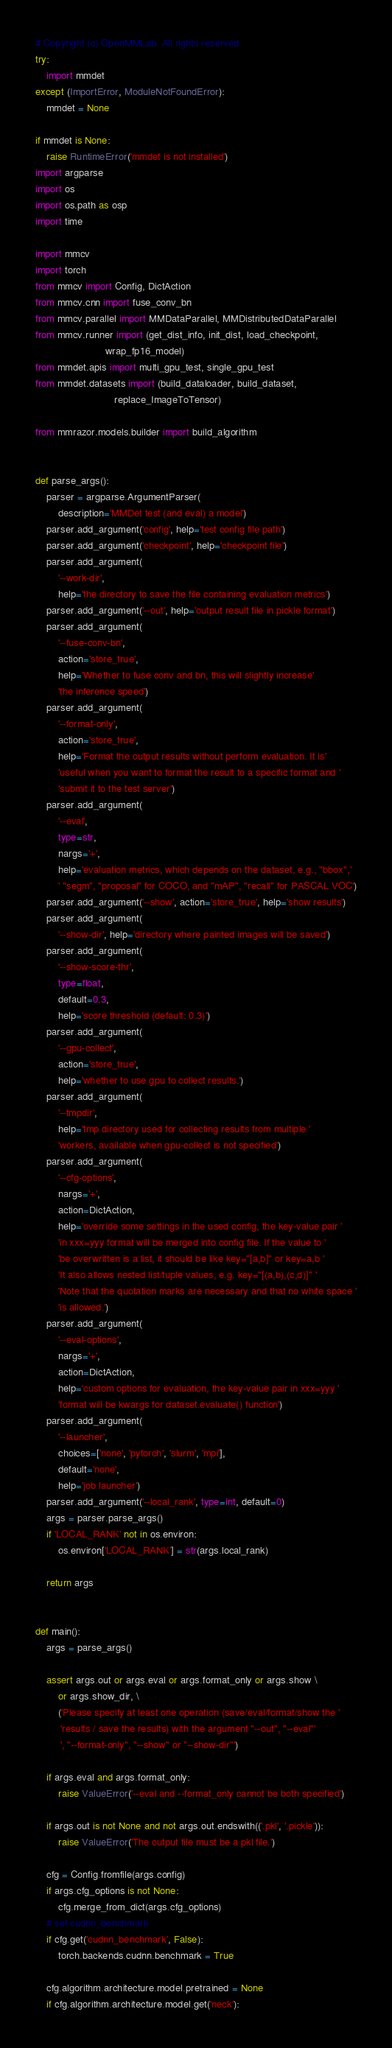<code> <loc_0><loc_0><loc_500><loc_500><_Python_># Copyright (c) OpenMMLab. All rights reserved.
try:
    import mmdet
except (ImportError, ModuleNotFoundError):
    mmdet = None

if mmdet is None:
    raise RuntimeError('mmdet is not installed')
import argparse
import os
import os.path as osp
import time

import mmcv
import torch
from mmcv import Config, DictAction
from mmcv.cnn import fuse_conv_bn
from mmcv.parallel import MMDataParallel, MMDistributedDataParallel
from mmcv.runner import (get_dist_info, init_dist, load_checkpoint,
                         wrap_fp16_model)
from mmdet.apis import multi_gpu_test, single_gpu_test
from mmdet.datasets import (build_dataloader, build_dataset,
                            replace_ImageToTensor)

from mmrazor.models.builder import build_algorithm


def parse_args():
    parser = argparse.ArgumentParser(
        description='MMDet test (and eval) a model')
    parser.add_argument('config', help='test config file path')
    parser.add_argument('checkpoint', help='checkpoint file')
    parser.add_argument(
        '--work-dir',
        help='the directory to save the file containing evaluation metrics')
    parser.add_argument('--out', help='output result file in pickle format')
    parser.add_argument(
        '--fuse-conv-bn',
        action='store_true',
        help='Whether to fuse conv and bn, this will slightly increase'
        'the inference speed')
    parser.add_argument(
        '--format-only',
        action='store_true',
        help='Format the output results without perform evaluation. It is'
        'useful when you want to format the result to a specific format and '
        'submit it to the test server')
    parser.add_argument(
        '--eval',
        type=str,
        nargs='+',
        help='evaluation metrics, which depends on the dataset, e.g., "bbox",'
        ' "segm", "proposal" for COCO, and "mAP", "recall" for PASCAL VOC')
    parser.add_argument('--show', action='store_true', help='show results')
    parser.add_argument(
        '--show-dir', help='directory where painted images will be saved')
    parser.add_argument(
        '--show-score-thr',
        type=float,
        default=0.3,
        help='score threshold (default: 0.3)')
    parser.add_argument(
        '--gpu-collect',
        action='store_true',
        help='whether to use gpu to collect results.')
    parser.add_argument(
        '--tmpdir',
        help='tmp directory used for collecting results from multiple '
        'workers, available when gpu-collect is not specified')
    parser.add_argument(
        '--cfg-options',
        nargs='+',
        action=DictAction,
        help='override some settings in the used config, the key-value pair '
        'in xxx=yyy format will be merged into config file. If the value to '
        'be overwritten is a list, it should be like key="[a,b]" or key=a,b '
        'It also allows nested list/tuple values, e.g. key="[(a,b),(c,d)]" '
        'Note that the quotation marks are necessary and that no white space '
        'is allowed.')
    parser.add_argument(
        '--eval-options',
        nargs='+',
        action=DictAction,
        help='custom options for evaluation, the key-value pair in xxx=yyy '
        'format will be kwargs for dataset.evaluate() function')
    parser.add_argument(
        '--launcher',
        choices=['none', 'pytorch', 'slurm', 'mpi'],
        default='none',
        help='job launcher')
    parser.add_argument('--local_rank', type=int, default=0)
    args = parser.parse_args()
    if 'LOCAL_RANK' not in os.environ:
        os.environ['LOCAL_RANK'] = str(args.local_rank)

    return args


def main():
    args = parse_args()

    assert args.out or args.eval or args.format_only or args.show \
        or args.show_dir, \
        ('Please specify at least one operation (save/eval/format/show the '
         'results / save the results) with the argument "--out", "--eval"'
         ', "--format-only", "--show" or "--show-dir"')

    if args.eval and args.format_only:
        raise ValueError('--eval and --format_only cannot be both specified')

    if args.out is not None and not args.out.endswith(('.pkl', '.pickle')):
        raise ValueError('The output file must be a pkl file.')

    cfg = Config.fromfile(args.config)
    if args.cfg_options is not None:
        cfg.merge_from_dict(args.cfg_options)
    # set cudnn_benchmark
    if cfg.get('cudnn_benchmark', False):
        torch.backends.cudnn.benchmark = True

    cfg.algorithm.architecture.model.pretrained = None
    if cfg.algorithm.architecture.model.get('neck'):</code> 